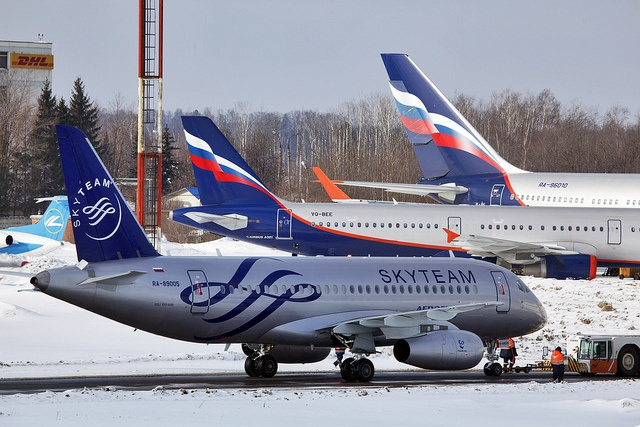Describe the objects in this image and their specific colors. I can see airplane in darkgray, navy, black, and gray tones, airplane in darkgray, lightgray, navy, and gray tones, airplane in darkgray, lightgray, and gray tones, airplane in darkgray, white, and lightblue tones, and truck in darkgray, black, gray, and maroon tones in this image. 